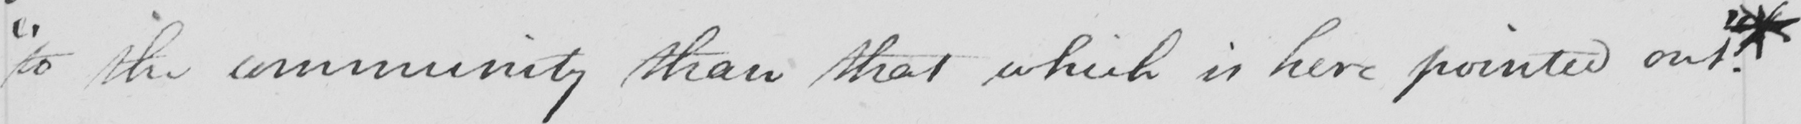What text is written in this handwritten line? " to the community than that which is here pointed out "  . * 